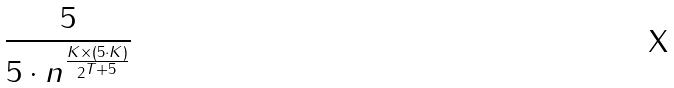<formula> <loc_0><loc_0><loc_500><loc_500>\frac { 5 } { 5 \cdot n ^ { \frac { K \times ( 5 \cdot K ) } { 2 ^ { T + 5 } } } }</formula> 